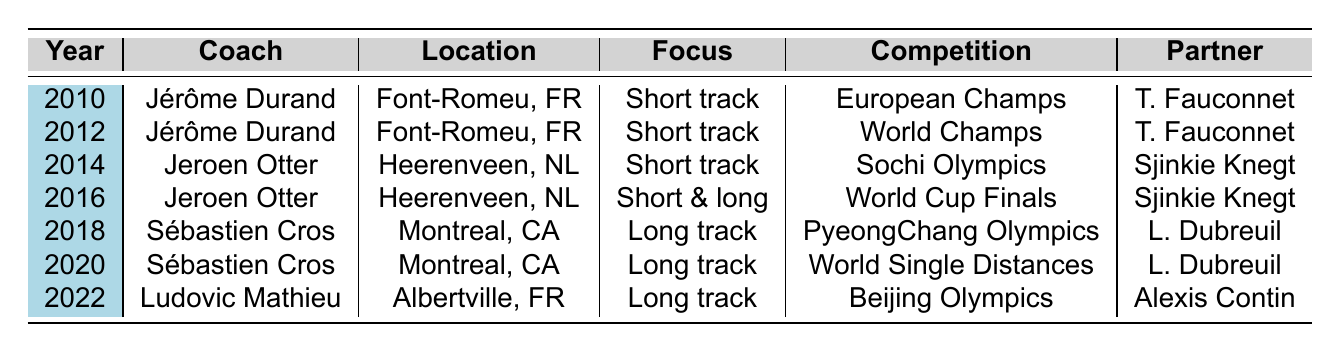What coach worked with Dubois during the 2014 season? Looking at the table, for the year 2014, the coach listed is Jeroen Otter.
Answer: Jeroen Otter Which location was used for training in 2016? According to the table, the training location for the year 2016 is Heerenveen, Netherlands.
Answer: Heerenveen, Netherlands How many times was Dubois coached by Jérôme Durand? In the table, Jérôme Durand is noted as the coach for 2010 and 2012, totaling 2 years.
Answer: 2 Did Dubois have the same training partner in both 2010 and 2012? The table shows that in both 2010 and 2012, Dubois trained with Thibaut Fauconnet, indicating that they were the same training partner.
Answer: Yes What was the focus of training in the years 2018 and 2020? Looking at the table, the focus for 2018 is Long track and for 2020 is also Long track. Thus, they share the same training focus.
Answer: Long track Which coach was with Dubois during his preparation for the 2018 PyeongChang Olympics? The table indicates that Sébastien Cros was the coach during the year 2018 when Dubois participated in the PyeongChang Olympics.
Answer: Sébastien Cros How many different training locations were used from 2010 to 2022? By reviewing the training locations in the table, we see Font-Romeu, Heerenveen, Montreal, and Albertville, totaling 4 unique training locations.
Answer: 4 In which major competition did Dubois compete during the years he trained in Montreal? From the years 2018 and 2020 (when training in Montreal), the major competitions were the PyeongChang Olympics and World Single Distances Championships.
Answer: 2 Was Dubois always coached by the same individual during his training in Font-Romeu? The table shows that he was coached by Jérôme Durand in both 2010 and 2012 while training in Font-Romeu, indicating consistency in coaching during those years.
Answer: Yes Which physiotherapist worked with Dubois during the Heerenveen training sessions? The table points out that Bart van Haaren served as the physiotherapist for both 2014 and 2016 when Dubois was training in Heerenveen.
Answer: Bart van Haaren 